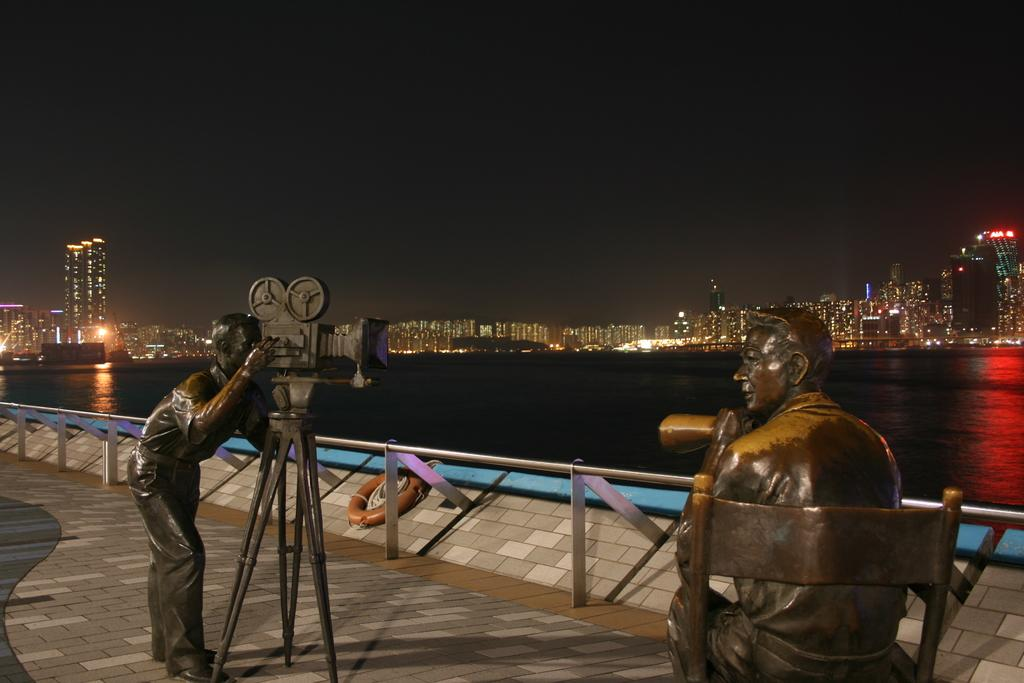What type of objects are depicted in the image? There are sculptures of men in the image. Are there any other sculptures besides the men? Yes, there are other sculptures in the image. What can be seen in the background of the image? In the background of the image, there is a fence, water, buildings, lights, the sky, and other unspecified things. What type of scarf is being worn by the sculpture of a man in the image? There are no scarves present on the sculptures of men in the image. What joke is being told by the sculptures in the image? There are no jokes being told by the sculptures in the image, as they are inanimate objects. 